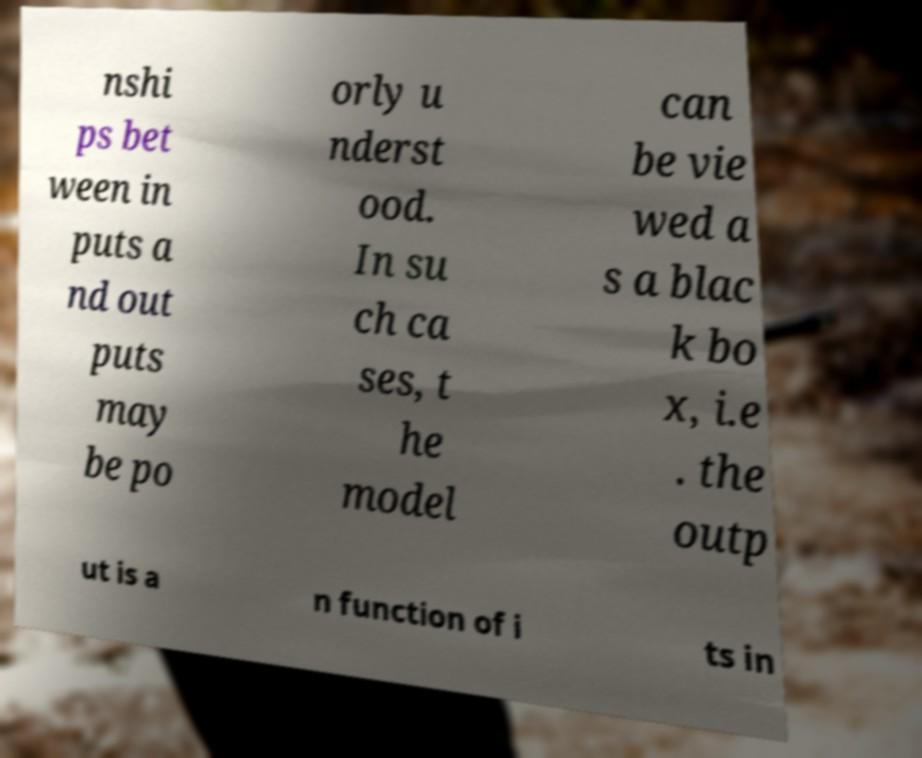Can you accurately transcribe the text from the provided image for me? nshi ps bet ween in puts a nd out puts may be po orly u nderst ood. In su ch ca ses, t he model can be vie wed a s a blac k bo x, i.e . the outp ut is a n function of i ts in 